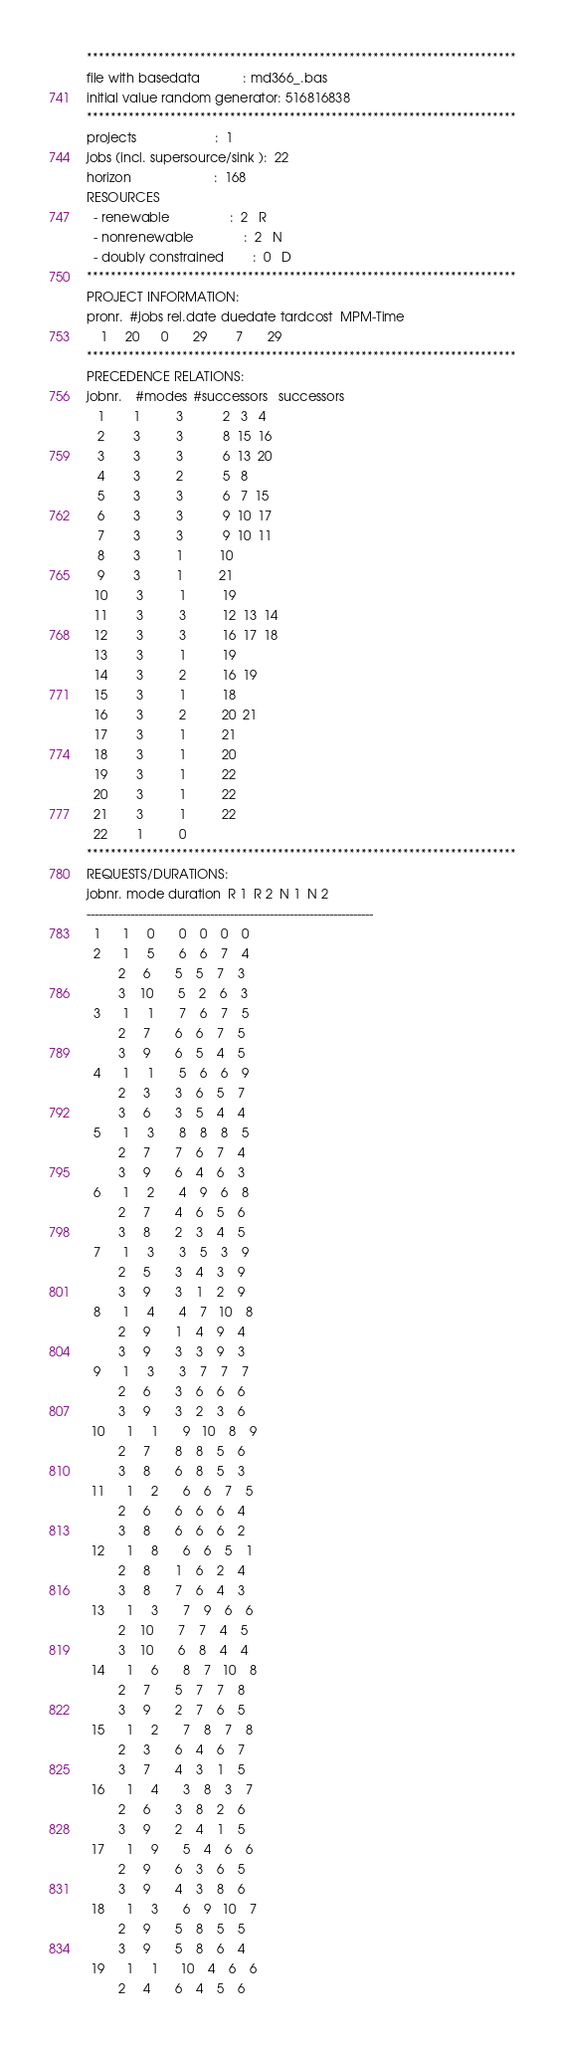Convert code to text. <code><loc_0><loc_0><loc_500><loc_500><_ObjectiveC_>************************************************************************
file with basedata            : md366_.bas
initial value random generator: 516816838
************************************************************************
projects                      :  1
jobs (incl. supersource/sink ):  22
horizon                       :  168
RESOURCES
  - renewable                 :  2   R
  - nonrenewable              :  2   N
  - doubly constrained        :  0   D
************************************************************************
PROJECT INFORMATION:
pronr.  #jobs rel.date duedate tardcost  MPM-Time
    1     20      0       29        7       29
************************************************************************
PRECEDENCE RELATIONS:
jobnr.    #modes  #successors   successors
   1        1          3           2   3   4
   2        3          3           8  15  16
   3        3          3           6  13  20
   4        3          2           5   8
   5        3          3           6   7  15
   6        3          3           9  10  17
   7        3          3           9  10  11
   8        3          1          10
   9        3          1          21
  10        3          1          19
  11        3          3          12  13  14
  12        3          3          16  17  18
  13        3          1          19
  14        3          2          16  19
  15        3          1          18
  16        3          2          20  21
  17        3          1          21
  18        3          1          20
  19        3          1          22
  20        3          1          22
  21        3          1          22
  22        1          0        
************************************************************************
REQUESTS/DURATIONS:
jobnr. mode duration  R 1  R 2  N 1  N 2
------------------------------------------------------------------------
  1      1     0       0    0    0    0
  2      1     5       6    6    7    4
         2     6       5    5    7    3
         3    10       5    2    6    3
  3      1     1       7    6    7    5
         2     7       6    6    7    5
         3     9       6    5    4    5
  4      1     1       5    6    6    9
         2     3       3    6    5    7
         3     6       3    5    4    4
  5      1     3       8    8    8    5
         2     7       7    6    7    4
         3     9       6    4    6    3
  6      1     2       4    9    6    8
         2     7       4    6    5    6
         3     8       2    3    4    5
  7      1     3       3    5    3    9
         2     5       3    4    3    9
         3     9       3    1    2    9
  8      1     4       4    7   10    8
         2     9       1    4    9    4
         3     9       3    3    9    3
  9      1     3       3    7    7    7
         2     6       3    6    6    6
         3     9       3    2    3    6
 10      1     1       9   10    8    9
         2     7       8    8    5    6
         3     8       6    8    5    3
 11      1     2       6    6    7    5
         2     6       6    6    6    4
         3     8       6    6    6    2
 12      1     8       6    6    5    1
         2     8       1    6    2    4
         3     8       7    6    4    3
 13      1     3       7    9    6    6
         2    10       7    7    4    5
         3    10       6    8    4    4
 14      1     6       8    7   10    8
         2     7       5    7    7    8
         3     9       2    7    6    5
 15      1     2       7    8    7    8
         2     3       6    4    6    7
         3     7       4    3    1    5
 16      1     4       3    8    3    7
         2     6       3    8    2    6
         3     9       2    4    1    5
 17      1     9       5    4    6    6
         2     9       6    3    6    5
         3     9       4    3    8    6
 18      1     3       6    9   10    7
         2     9       5    8    5    5
         3     9       5    8    6    4
 19      1     1      10    4    6    6
         2     4       6    4    5    6</code> 